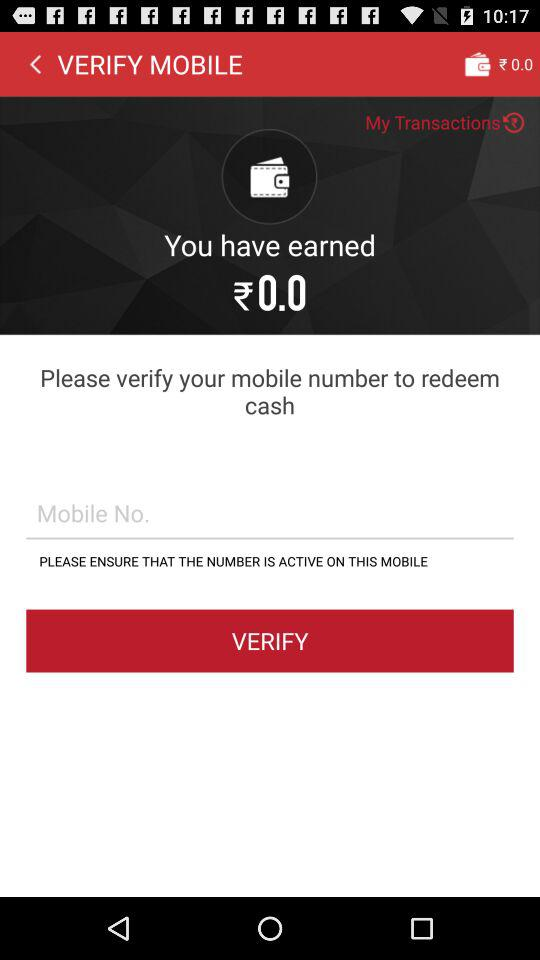How much money do I have in my wallet?
Answer the question using a single word or phrase. ₹0.0 